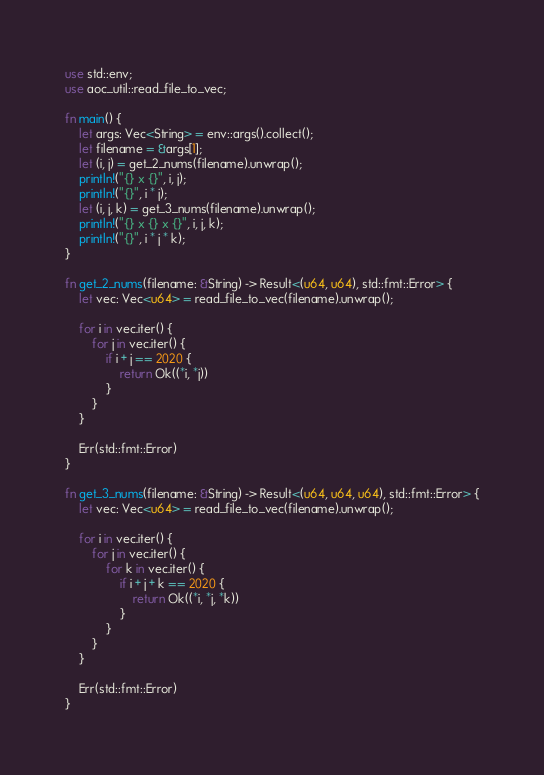<code> <loc_0><loc_0><loc_500><loc_500><_Rust_>use std::env;
use aoc_util::read_file_to_vec;

fn main() {
    let args: Vec<String> = env::args().collect();
    let filename = &args[1];
    let (i, j) = get_2_nums(filename).unwrap();
    println!("{} x {}", i, j);
    println!("{}", i * j);    
    let (i, j, k) = get_3_nums(filename).unwrap();
    println!("{} x {} x {}", i, j, k);
    println!("{}", i * j * k);    
}

fn get_2_nums(filename: &String) -> Result<(u64, u64), std::fmt::Error> {
    let vec: Vec<u64> = read_file_to_vec(filename).unwrap();
    
    for i in vec.iter() {
        for j in vec.iter() {
            if i + j == 2020 {
                return Ok((*i, *j))
            }
        }
    }

    Err(std::fmt::Error)
}

fn get_3_nums(filename: &String) -> Result<(u64, u64, u64), std::fmt::Error> {
    let vec: Vec<u64> = read_file_to_vec(filename).unwrap();
    
    for i in vec.iter() {
        for j in vec.iter() {
            for k in vec.iter() {
                if i + j + k == 2020 {
                    return Ok((*i, *j, *k))
                }
            }
        }
    }

    Err(std::fmt::Error)
}</code> 